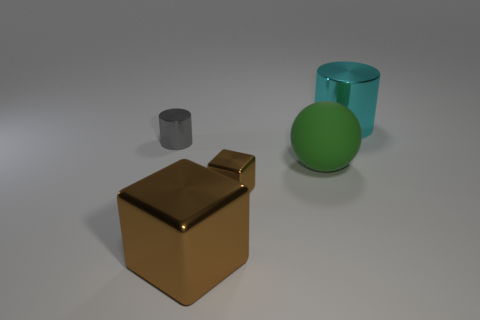Are there any patterns or textures visible on these objects? The objects in the image have a smooth and clean surface with no visible textures or patterns, emphasizing their geometric shapes. 